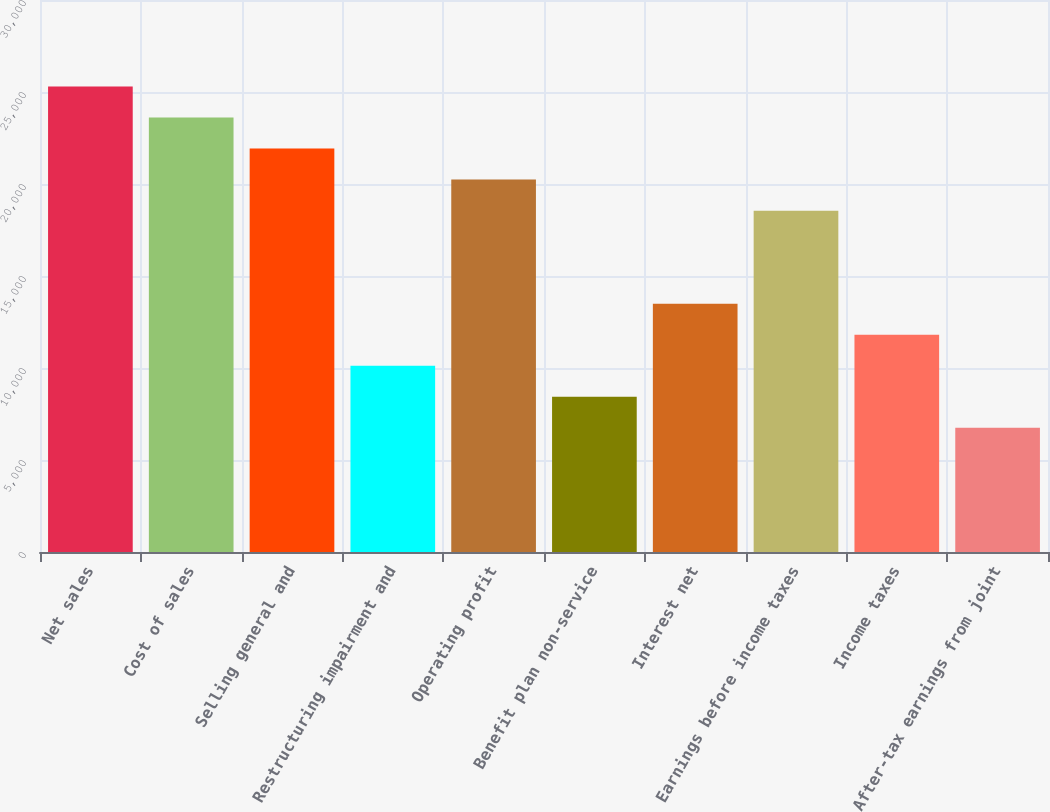Convert chart to OTSL. <chart><loc_0><loc_0><loc_500><loc_500><bar_chart><fcel>Net sales<fcel>Cost of sales<fcel>Selling general and<fcel>Restructuring impairment and<fcel>Operating profit<fcel>Benefit plan non-service<fcel>Interest net<fcel>Earnings before income taxes<fcel>Income taxes<fcel>After-tax earnings from joint<nl><fcel>25296.8<fcel>23610.4<fcel>21924.1<fcel>10119.9<fcel>20237.8<fcel>8433.56<fcel>13492.5<fcel>18551.5<fcel>11806.2<fcel>6747.24<nl></chart> 